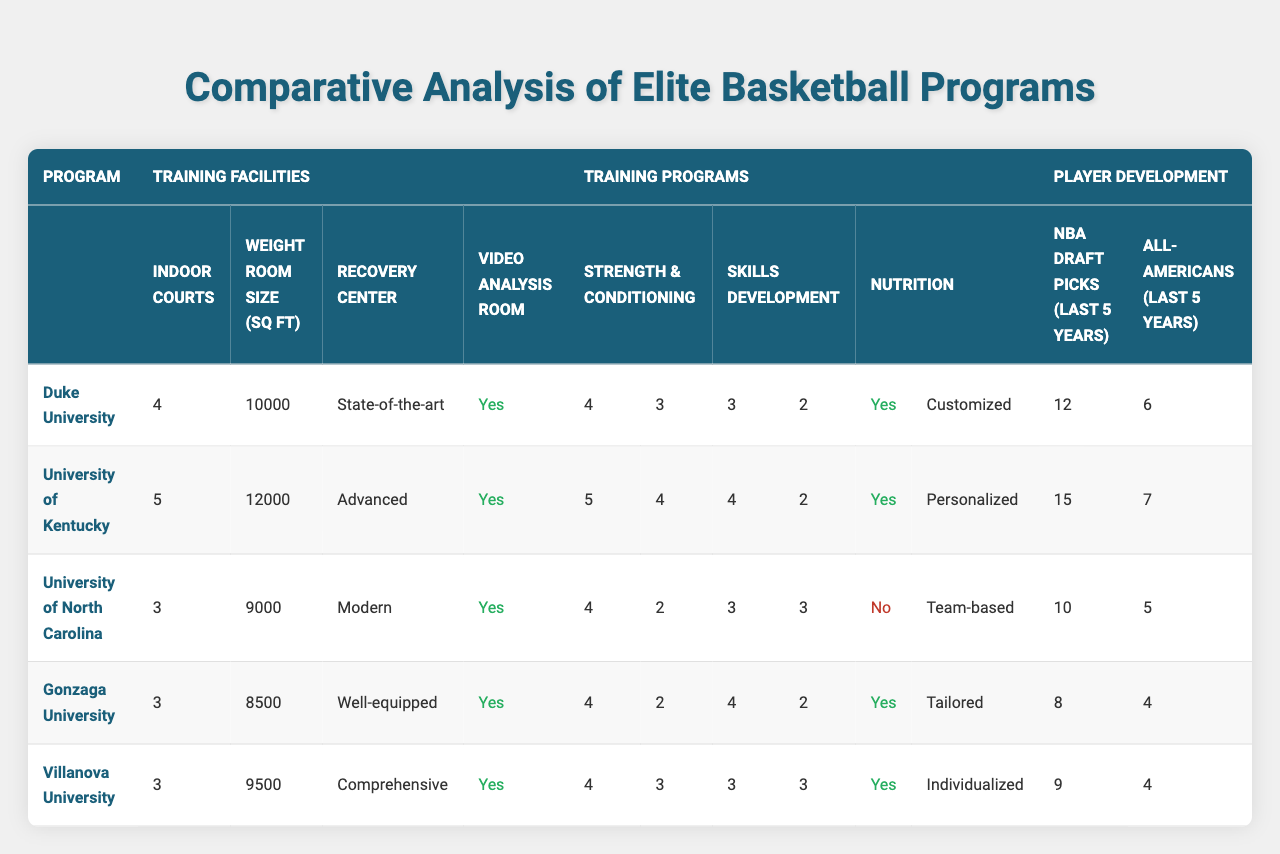What is the maximum weight room size among the programs? The weight room sizes are as follows: Duke (10000 sq ft), Kentucky (12000 sq ft), North Carolina (9000 sq ft), Gonzaga (8500 sq ft), and Villanova (9500 sq ft). The maximum value is 12000 sq ft from Kentucky.
Answer: 12000 sq ft Which program has the least number of indoor courts? The indoor courts for each program are: Duke (4), Kentucky (5), North Carolina (3), Gonzaga (3), and Villanova (3). North Carolina, Gonzaga, and Villanova each have 3 indoor courts, the least among the programs.
Answer: North Carolina, Gonzaga, and Villanova Do all programs have a video analysis room? Every program listed has a video analysis room indicated by "true" under that column. Therefore, the answer is yes.
Answer: Yes What is the average number of NBA draft picks over the last five years among all programs? The NBA draft picks are: Duke (12), Kentucky (15), North Carolina (10), Gonzaga (8), and Villanova (9). The total is 12 + 15 + 10 + 8 + 9 = 54. There are 5 programs, so the average is 54 / 5 = 10.8.
Answer: 10.8 Which program has the most sessions per week for strength and conditioning, and how many sessions do they have? For strength and conditioning, the sessions per week are: Duke (4), Kentucky (5), North Carolina (4), Gonzaga (4), and Villanova (4). Kentucky has the most with 5 sessions per week.
Answer: Kentucky, 5 How many personal trainers does Gonzaga have compared to Duke? Gonzaga has 2 personal trainers, while Duke has 3. The difference is 3 - 2 = 1.
Answer: 1 fewer trainer Is the meal plan at North Carolina team-based or personalized? North Carolina's meal plan is labeled as "Team-based." This indicates that it follows a collective approach rather than an individual one.
Answer: Team-based What is the total number of All-Americans produced by all programs over the last five years? The number of All-Americans is: Duke (6), Kentucky (7), North Carolina (5), Gonzaga (4), Villanova (4). Adding these gives 6 + 7 + 5 + 4 + 4 = 26.
Answer: 26 Which program has the lowest number of personal trainers, and how many do they have? The number of personal trainers for each program: Duke (3), Kentucky (4), North Carolina (2), Gonzaga (2), and Villanova (3). North Carolina and Gonzaga each have the lowest count with 2 trainers.
Answer: North Carolina and Gonzaga, 2 What is the difference in the number of individual skills development sessions between UK and DU? For skills development, individual sessions are: UK (4) and DU (3). The difference is 4 - 3 = 1 additional session for UK.
Answer: 1 more session for UK 